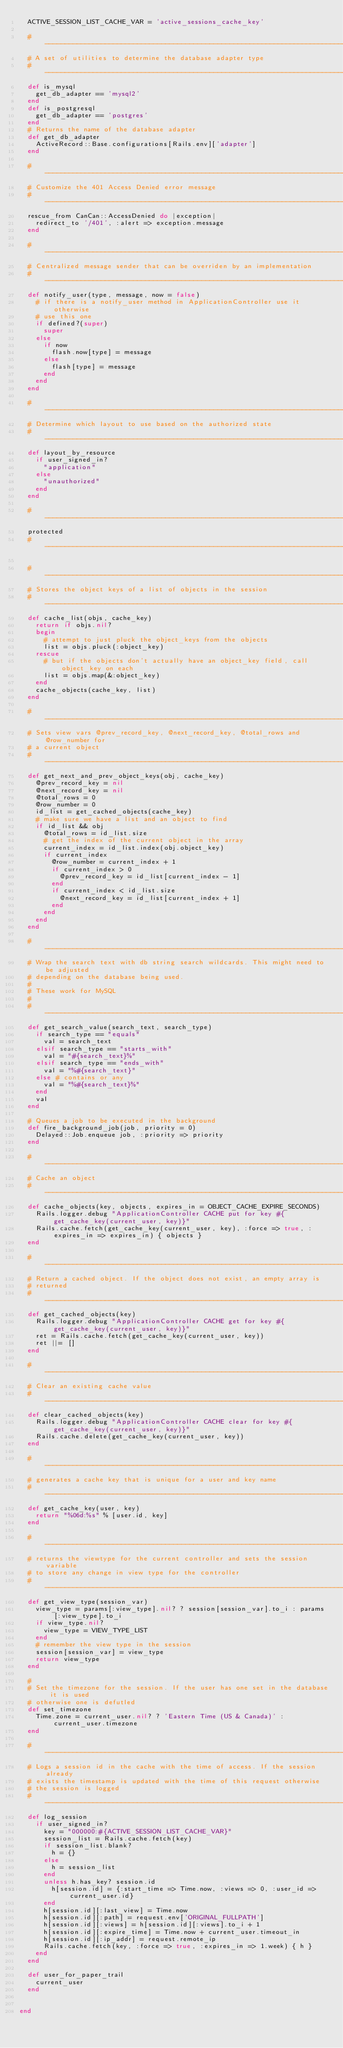Convert code to text. <code><loc_0><loc_0><loc_500><loc_500><_Ruby_>  ACTIVE_SESSION_LIST_CACHE_VAR = 'active_sessions_cache_key'

  #-----------------------------------------------------------------------------
  # A set of utilities to determine the database adapter type
  #-----------------------------------------------------------------------------
  def is_mysql
    get_db_adapter == 'mysql2'
  end
  def is_postgresql
    get_db_adapter == 'postgres'
  end
  # Returns the name of the database adapter
  def get_db_adapter
    ActiveRecord::Base.configurations[Rails.env]['adapter']
  end

  #-----------------------------------------------------------------------------
  # Customize the 401 Access Denied error message
  #-----------------------------------------------------------------------------
  rescue_from CanCan::AccessDenied do |exception|
    redirect_to '/401', :alert => exception.message
  end

  #-----------------------------------------------------------------------------
  # Centralized message sender that can be overriden by an implementation
  #-----------------------------------------------------------------------------
  def notify_user(type, message, now = false)
    # if there is a notify_user method in ApplicationController use it otherwise
    # use this one
    if defined?(super)
      super
    else
      if now
        flash.now[type] = message
      else
        flash[type] = message
      end
    end
  end

  #-----------------------------------------------------------------------------
  # Determine which layout to use based on the authorized state
  #-----------------------------------------------------------------------------
  def layout_by_resource
    if user_signed_in?
      "application"
    else
      "unauthorized"
    end
  end

  #-----------------------------------------------------------------------------
  protected
  #-----------------------------------------------------------------------------

  #-----------------------------------------------------------------------------
  # Stores the object keys of a list of objects in the session
  #-----------------------------------------------------------------------------
  def cache_list(objs, cache_key)
    return if objs.nil?
    begin
      # attempt to just pluck the object_keys from the objects
      list = objs.pluck(:object_key)
    rescue
      # but if the objects don't actually have an object_key field, call object_key on each
      list = objs.map(&:object_key)
    end
    cache_objects(cache_key, list)
  end

  #-----------------------------------------------------------------------------
  # Sets view vars @prev_record_key, @next_record_key, @total_rows and @row_number for
  # a current object
  #-----------------------------------------------------------------------------
  def get_next_and_prev_object_keys(obj, cache_key)
    @prev_record_key = nil
    @next_record_key = nil
    @total_rows = 0
    @row_number = 0
    id_list = get_cached_objects(cache_key)
    # make sure we have a list and an object to find
    if id_list && obj
      @total_rows = id_list.size
      # get the index of the current object in the array
      current_index = id_list.index(obj.object_key)
      if current_index
        @row_number = current_index + 1
        if current_index > 0
          @prev_record_key = id_list[current_index - 1]
        end
        if current_index < id_list.size
          @next_record_key = id_list[current_index + 1]
        end
      end
    end
  end

  #-----------------------------------------------------------------------------
  # Wrap the search text with db string search wildcards. This might need to be adjusted
  # depending on the database being used.
  #
  # These work for MySQL
  #
  #-----------------------------------------------------------------------------
  def get_search_value(search_text, search_type)
    if search_type == "equals"
      val = search_text
    elsif search_type == "starts_with"
      val = "#{search_text}%"
    elsif search_type == "ends_with"
      val = "%#{search_text}"
    else # contains or any
      val = "%#{search_text}%"
    end
    val
  end

  # Queues a job to be executed in the background
  def fire_background_job(job, priority = 0)
    Delayed::Job.enqueue job, :priority => priority
  end

  #-----------------------------------------------------------------------------
  # Cache an object
  #-----------------------------------------------------------------------------
  def cache_objects(key, objects, expires_in = OBJECT_CACHE_EXPIRE_SECONDS)
    Rails.logger.debug "ApplicationController CACHE put for key #{get_cache_key(current_user, key)}"
    Rails.cache.fetch(get_cache_key(current_user, key), :force => true, :expires_in => expires_in) { objects }
  end

  #-----------------------------------------------------------------------------
  # Return a cached object. If the object does not exist, an empty array is
  # returned
  #-----------------------------------------------------------------------------
  def get_cached_objects(key)
    Rails.logger.debug "ApplicationController CACHE get for key #{get_cache_key(current_user, key)}"
    ret = Rails.cache.fetch(get_cache_key(current_user, key))
    ret ||= []
  end

  #-----------------------------------------------------------------------------
  # Clear an existing cache value
  #-----------------------------------------------------------------------------
  def clear_cached_objects(key)
    Rails.logger.debug "ApplicationController CACHE clear for key #{get_cache_key(current_user, key)}"
    Rails.cache.delete(get_cache_key(current_user, key))
  end

  #-----------------------------------------------------------------------------
  # generates a cache key that is unique for a user and key name
  #-----------------------------------------------------------------------------
  def get_cache_key(user, key)
    return "%06d:%s" % [user.id, key]
  end

  #-----------------------------------------------------------------------------
  # returns the viewtype for the current controller and sets the session variable
  # to store any change in view type for the controller
  #-----------------------------------------------------------------------------
  def get_view_type(session_var)
    view_type = params[:view_type].nil? ? session[session_var].to_i : params[:view_type].to_i
    if view_type.nil?
      view_type = VIEW_TYPE_LIST
    end
    # remember the view type in the session
    session[session_var] = view_type
    return view_type
  end

  #
  # Set the timezone for the session. If the user has one set in the database it is used
  # otherwise one is defutled
  def set_timezone
    Time.zone = current_user.nil? ? 'Eastern Time (US & Canada)' : current_user.timezone
  end

  #-----------------------------------------------------------------------------
  # Logs a session id in the cache with the time of access. If the session already
  # exists the timestamp is updated with the time of this request otherwise
  # the session is logged
  #-----------------------------------------------------------------------------
  def log_session
    if user_signed_in?
      key = "000000:#{ACTIVE_SESSION_LIST_CACHE_VAR}"
      session_list = Rails.cache.fetch(key)
      if session_list.blank?
        h = {}
      else
        h = session_list
      end
      unless h.has_key? session.id
        h[session.id] = {:start_time => Time.now, :views => 0, :user_id => current_user.id}
      end
      h[session.id][:last_view] = Time.now
      h[session.id][:path] = request.env['ORIGINAL_FULLPATH']
      h[session.id][:views] = h[session.id][:views].to_i + 1
      h[session.id][:expire_time] = Time.now + current_user.timeout_in
      h[session.id][:ip_addr] = request.remote_ip
      Rails.cache.fetch(key, :force => true, :expires_in => 1.week) { h }
    end
  end

  def user_for_paper_trail
    current_user
  end


end
</code> 